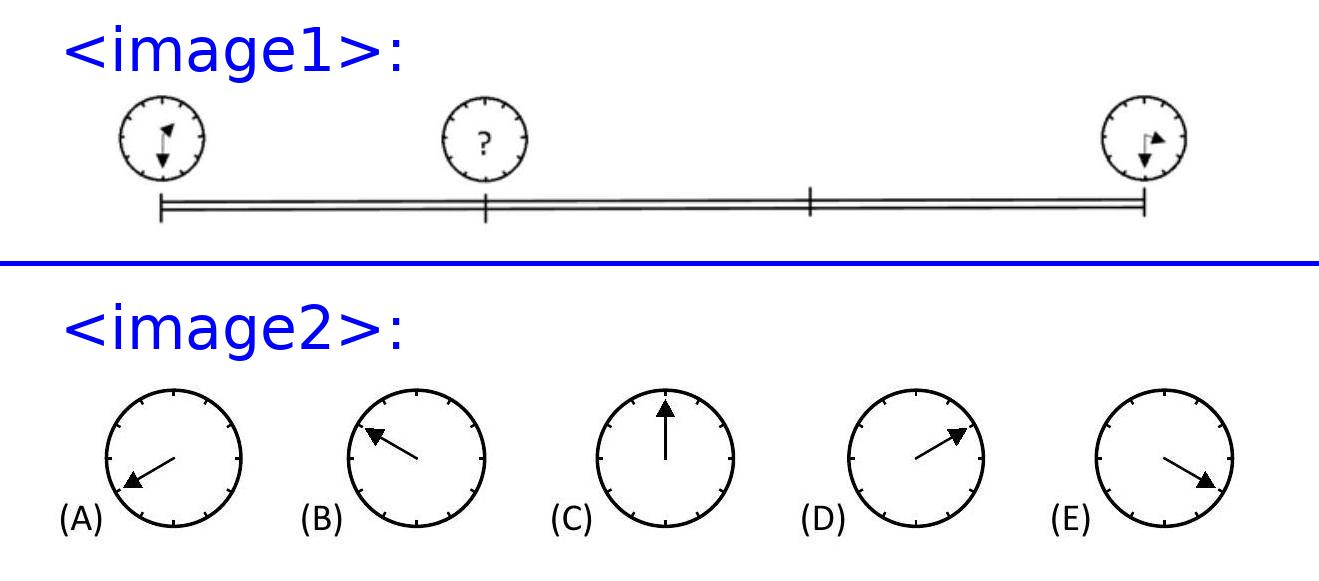How might the time elapsed affect Patricia's perception of time considering she's observing the clock only at the start and end of her journey? Patricia's infrequent checks on the clock can lead her to feel like time is either passing more quickly or slowly than it really is. This psychological effect, often referred to as the 'stopped-clock illusion', occurs because she is not continuously monitoring the passage of time, allowing her personal perception to drift from the actual time elapsed. What might be going through her mind during this period? During her drive, Patricia may be thinking about her upcoming engagement with her friend, the route she is taking, or possibly even daydreaming, which can all alter her subjective experience of time, making short durations feel longer and long durations feel shorter. 